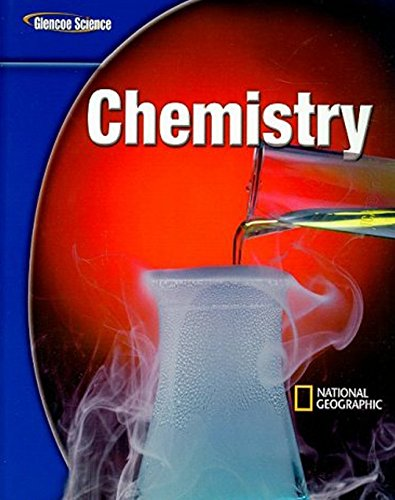What type of book is this? This is an educational textbook specifically designed for middle school students, focusing on the subject of chemistry. 